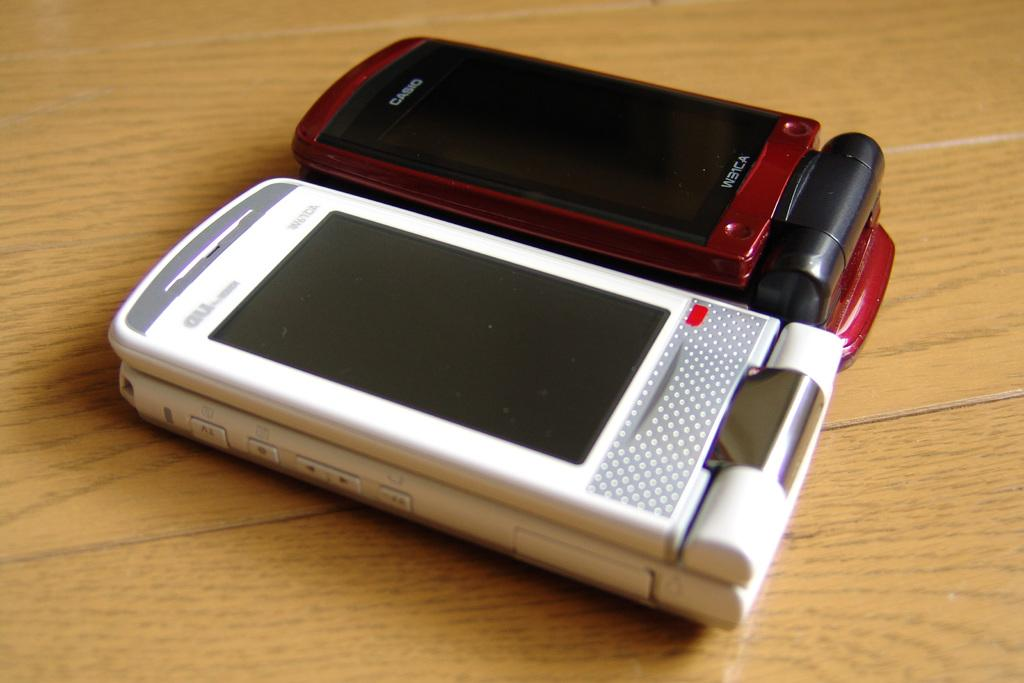<image>
Relay a brief, clear account of the picture shown. Casio used to manufacture cell phones back when flip style phones were popular. 